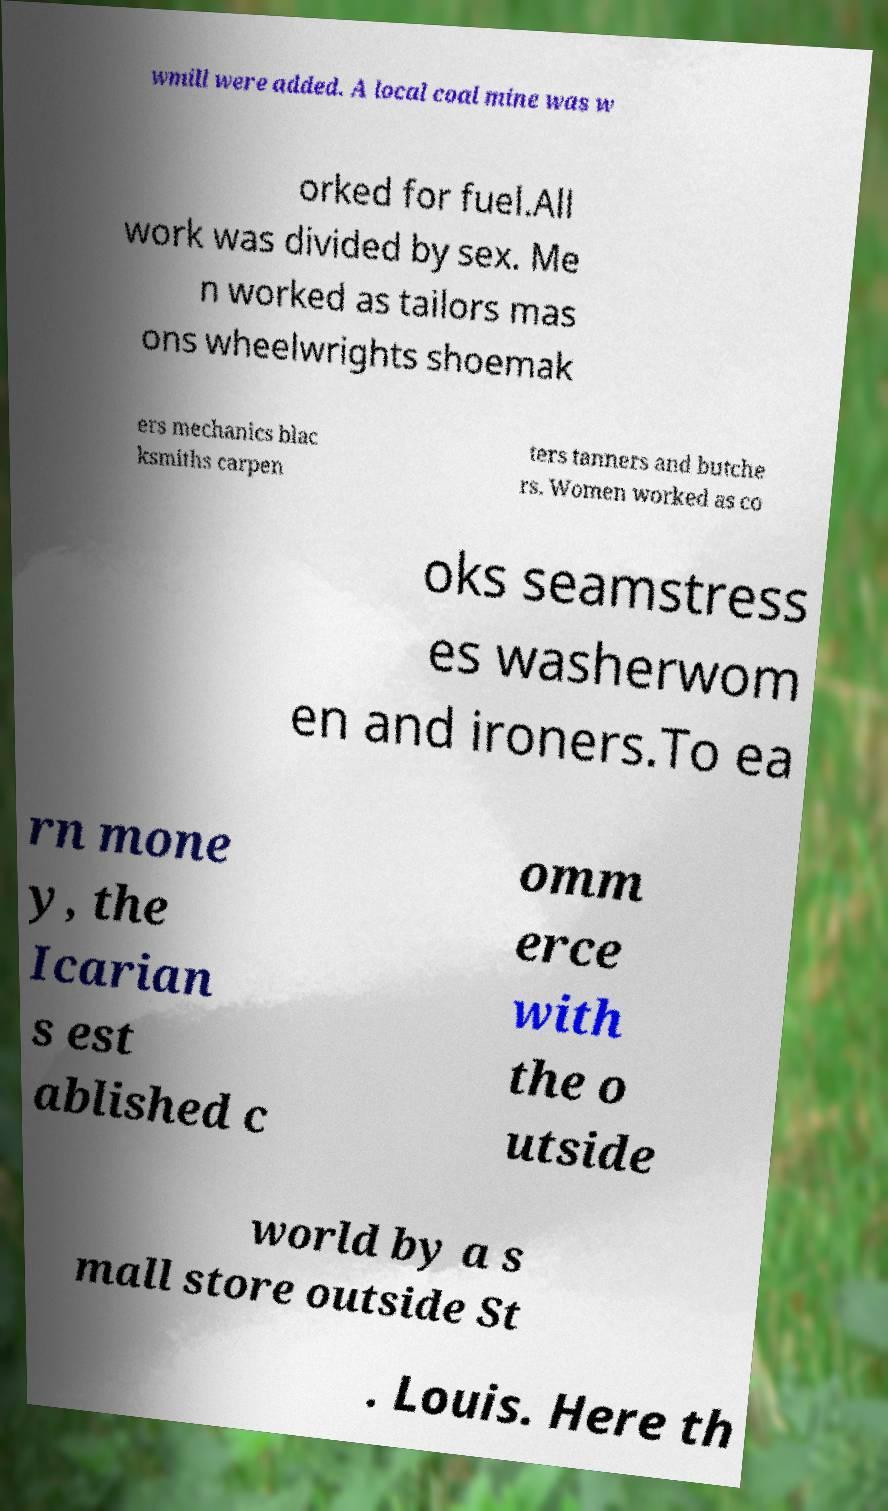Can you accurately transcribe the text from the provided image for me? wmill were added. A local coal mine was w orked for fuel.All work was divided by sex. Me n worked as tailors mas ons wheelwrights shoemak ers mechanics blac ksmiths carpen ters tanners and butche rs. Women worked as co oks seamstress es washerwom en and ironers.To ea rn mone y, the Icarian s est ablished c omm erce with the o utside world by a s mall store outside St . Louis. Here th 